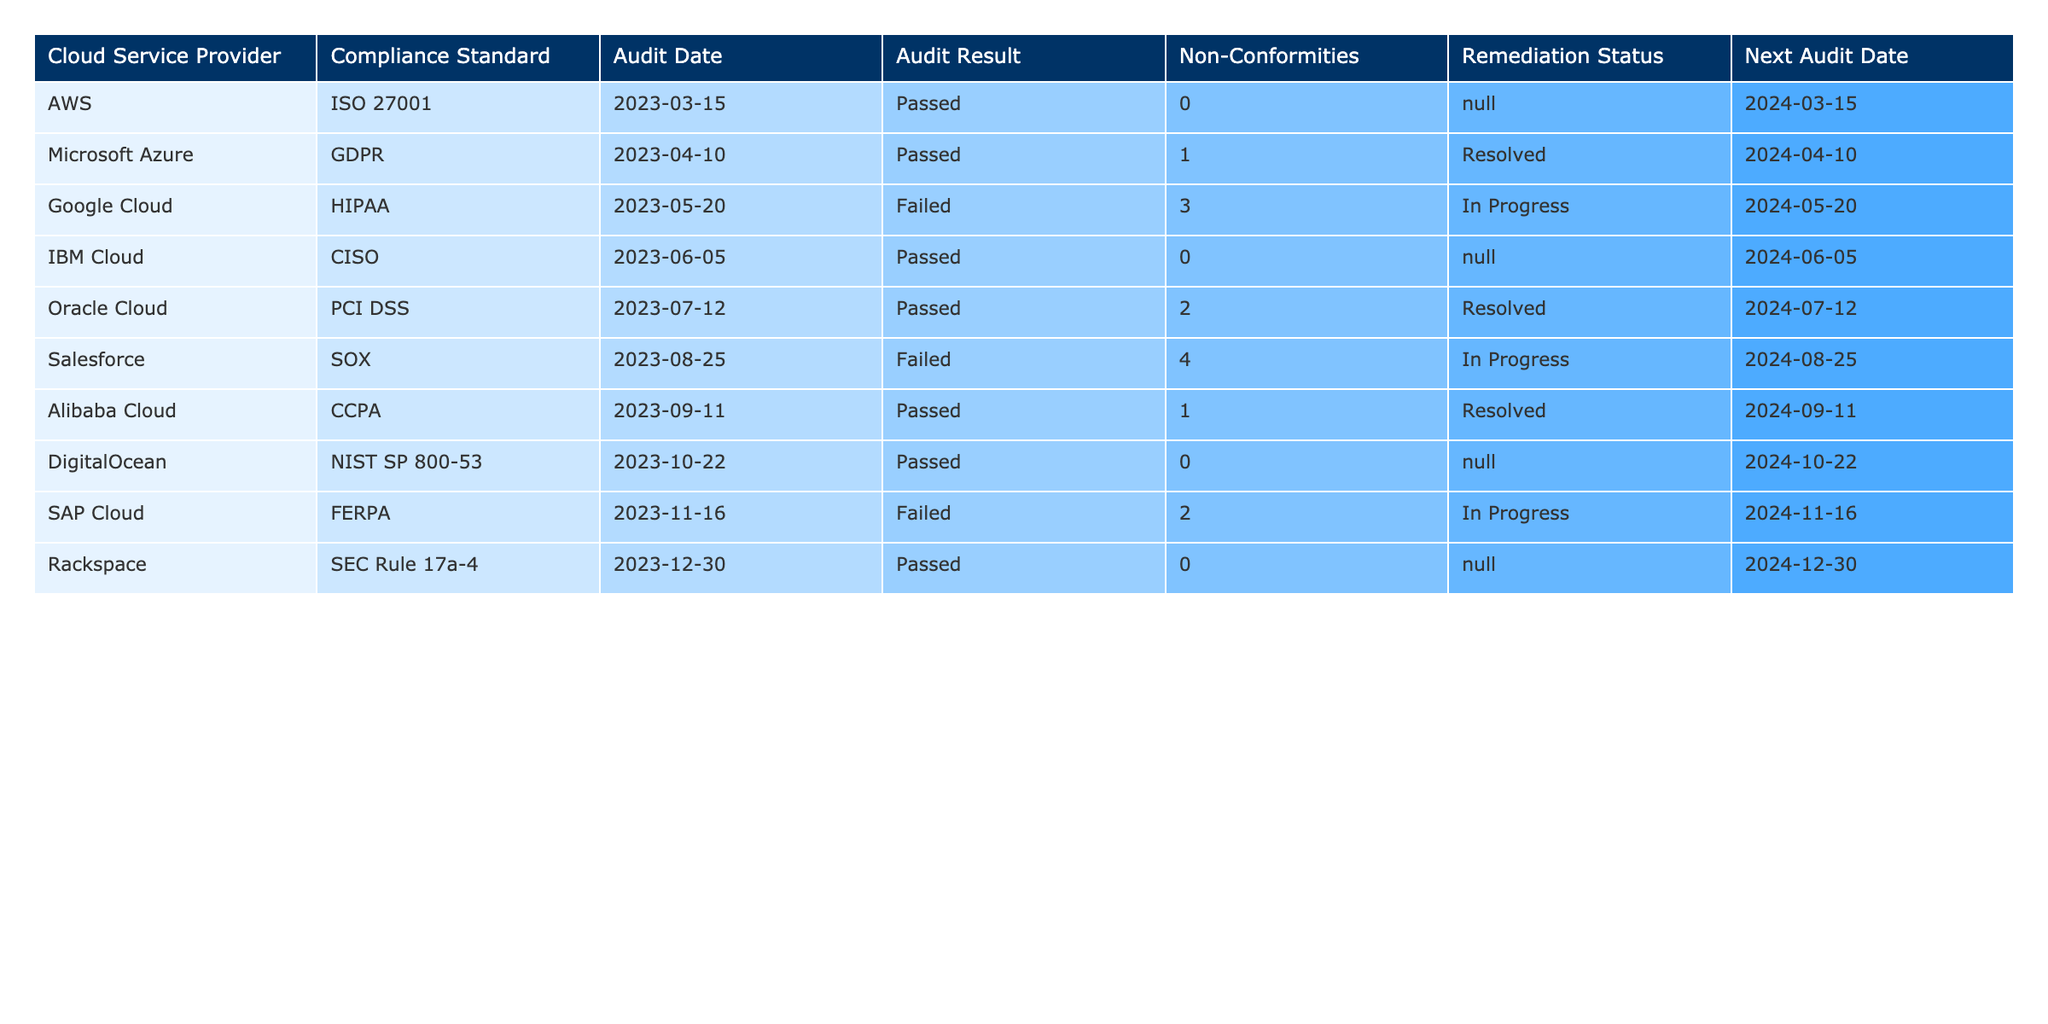What is the compliance standard for Microsoft Azure? The table lists Microsoft Azure under the "Compliance Standard" column, where it shows "GDPR".
Answer: GDPR How many non-conformities were found in the Google Cloud audit? Upon checking the "Non-Conformities" column for Google Cloud, it states there were "3" non-conformities.
Answer: 3 Did Rackspace pass its compliance audit? The "Audit Result" for Rackspace in the table indicates "Passed".
Answer: Yes Which cloud service provider had the highest number of non-conformities? Comparing the "Non-Conformities" column across all providers, Salesforce shows "4" non-conformities, which is the most.
Answer: Salesforce What is the remediation status for the non-conformities found in Salesforce? The table indicates that the remediation status for Salesforce is "In Progress".
Answer: In Progress How many cloud service providers passed their compliance audits? By counting entries in the "Audit Result" column, I see 6 providers have "Passed" as their result.
Answer: 6 What is the next audit date for Oracle Cloud? The "Next Audit Date" column shows that Oracle Cloud's next audit is scheduled for "2024-07-12".
Answer: 2024-07-12 What percentage of cloud service providers failed their compliance audits? There are 3 failures out of 10 total providers. Calculating the percentage gives (3/10)*100 = 30%.
Answer: 30% Which compliance standards had audits that resulted in failures? Reviewing the "Compliance Standard" column for the "Failed" results shows that HIPAA, SOX, and FERPA are the standards with failures.
Answer: HIPAA, SOX, FERPA If Google Cloud's non-conformities are resolved by the next audit date, how many total non-conformities will remain for that provider after the next audit? Currently, Google Cloud has 3 non-conformities. If they are resolved, the count will drop to 0 for the next audit.
Answer: 0 